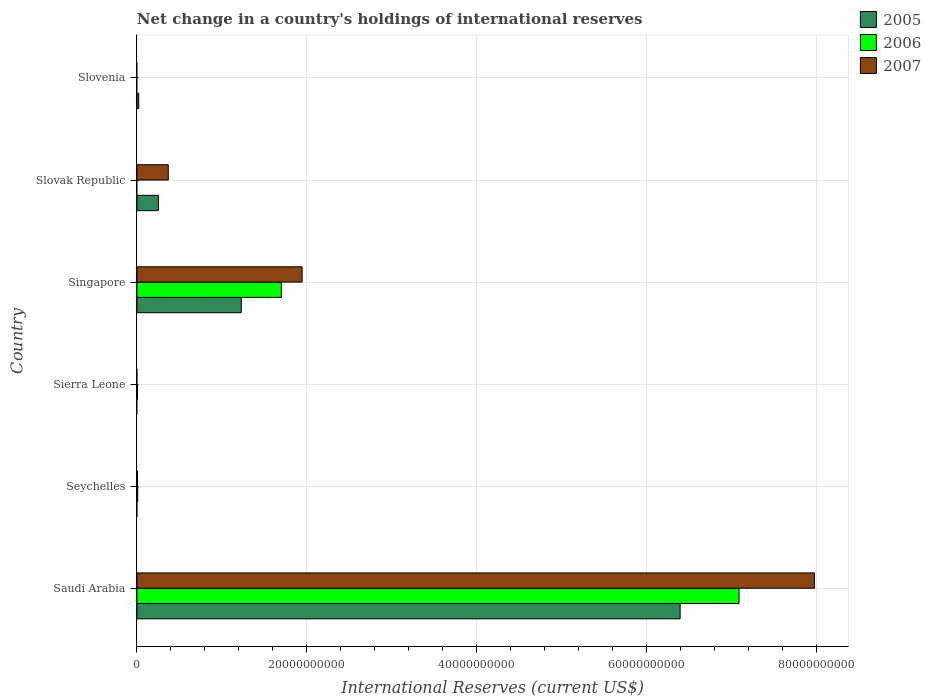How many bars are there on the 4th tick from the bottom?
Provide a succinct answer. 3. What is the label of the 3rd group of bars from the top?
Your answer should be compact. Singapore. In how many cases, is the number of bars for a given country not equal to the number of legend labels?
Offer a very short reply. 4. What is the international reserves in 2005 in Slovak Republic?
Offer a very short reply. 2.52e+09. Across all countries, what is the maximum international reserves in 2005?
Give a very brief answer. 6.40e+1. In which country was the international reserves in 2007 maximum?
Your answer should be compact. Saudi Arabia. What is the total international reserves in 2007 in the graph?
Offer a terse response. 1.03e+11. What is the difference between the international reserves in 2006 in Saudi Arabia and that in Singapore?
Keep it short and to the point. 5.39e+1. What is the difference between the international reserves in 2005 in Slovenia and the international reserves in 2007 in Seychelles?
Your response must be concise. 1.45e+08. What is the average international reserves in 2006 per country?
Your answer should be very brief. 1.47e+1. What is the difference between the international reserves in 2005 and international reserves in 2006 in Saudi Arabia?
Your response must be concise. -6.94e+09. In how many countries, is the international reserves in 2005 greater than 64000000000 US$?
Keep it short and to the point. 0. What is the ratio of the international reserves in 2007 in Saudi Arabia to that in Singapore?
Offer a very short reply. 4.1. What is the difference between the highest and the second highest international reserves in 2006?
Give a very brief answer. 5.39e+1. What is the difference between the highest and the lowest international reserves in 2005?
Your answer should be compact. 6.40e+1. Is the sum of the international reserves in 2007 in Saudi Arabia and Slovak Republic greater than the maximum international reserves in 2005 across all countries?
Ensure brevity in your answer.  Yes. Are all the bars in the graph horizontal?
Your answer should be very brief. Yes. Does the graph contain any zero values?
Your response must be concise. Yes. Does the graph contain grids?
Your answer should be compact. Yes. Where does the legend appear in the graph?
Offer a terse response. Top right. What is the title of the graph?
Ensure brevity in your answer.  Net change in a country's holdings of international reserves. Does "1975" appear as one of the legend labels in the graph?
Keep it short and to the point. No. What is the label or title of the X-axis?
Provide a succinct answer. International Reserves (current US$). What is the International Reserves (current US$) of 2005 in Saudi Arabia?
Ensure brevity in your answer.  6.40e+1. What is the International Reserves (current US$) in 2006 in Saudi Arabia?
Your answer should be very brief. 7.09e+1. What is the International Reserves (current US$) in 2007 in Saudi Arabia?
Keep it short and to the point. 7.98e+1. What is the International Reserves (current US$) in 2005 in Seychelles?
Your answer should be compact. 0. What is the International Reserves (current US$) of 2006 in Seychelles?
Your answer should be very brief. 9.32e+07. What is the International Reserves (current US$) of 2007 in Seychelles?
Provide a succinct answer. 6.12e+07. What is the International Reserves (current US$) of 2006 in Sierra Leone?
Ensure brevity in your answer.  6.04e+07. What is the International Reserves (current US$) in 2005 in Singapore?
Your answer should be very brief. 1.23e+1. What is the International Reserves (current US$) in 2006 in Singapore?
Offer a terse response. 1.70e+1. What is the International Reserves (current US$) in 2007 in Singapore?
Keep it short and to the point. 1.94e+1. What is the International Reserves (current US$) of 2005 in Slovak Republic?
Your answer should be compact. 2.52e+09. What is the International Reserves (current US$) of 2006 in Slovak Republic?
Provide a succinct answer. 0. What is the International Reserves (current US$) in 2007 in Slovak Republic?
Offer a very short reply. 3.69e+09. What is the International Reserves (current US$) in 2005 in Slovenia?
Provide a succinct answer. 2.06e+08. What is the International Reserves (current US$) of 2007 in Slovenia?
Your answer should be very brief. 0. Across all countries, what is the maximum International Reserves (current US$) in 2005?
Keep it short and to the point. 6.40e+1. Across all countries, what is the maximum International Reserves (current US$) in 2006?
Offer a terse response. 7.09e+1. Across all countries, what is the maximum International Reserves (current US$) in 2007?
Give a very brief answer. 7.98e+1. Across all countries, what is the minimum International Reserves (current US$) of 2006?
Give a very brief answer. 0. What is the total International Reserves (current US$) in 2005 in the graph?
Provide a short and direct response. 7.90e+1. What is the total International Reserves (current US$) of 2006 in the graph?
Offer a terse response. 8.81e+1. What is the total International Reserves (current US$) in 2007 in the graph?
Provide a succinct answer. 1.03e+11. What is the difference between the International Reserves (current US$) of 2006 in Saudi Arabia and that in Seychelles?
Offer a very short reply. 7.08e+1. What is the difference between the International Reserves (current US$) of 2007 in Saudi Arabia and that in Seychelles?
Your answer should be very brief. 7.97e+1. What is the difference between the International Reserves (current US$) of 2006 in Saudi Arabia and that in Sierra Leone?
Your answer should be very brief. 7.08e+1. What is the difference between the International Reserves (current US$) of 2005 in Saudi Arabia and that in Singapore?
Offer a terse response. 5.17e+1. What is the difference between the International Reserves (current US$) in 2006 in Saudi Arabia and that in Singapore?
Your answer should be very brief. 5.39e+1. What is the difference between the International Reserves (current US$) in 2007 in Saudi Arabia and that in Singapore?
Your response must be concise. 6.03e+1. What is the difference between the International Reserves (current US$) in 2005 in Saudi Arabia and that in Slovak Republic?
Your response must be concise. 6.14e+1. What is the difference between the International Reserves (current US$) of 2007 in Saudi Arabia and that in Slovak Republic?
Your answer should be very brief. 7.61e+1. What is the difference between the International Reserves (current US$) in 2005 in Saudi Arabia and that in Slovenia?
Offer a very short reply. 6.38e+1. What is the difference between the International Reserves (current US$) in 2006 in Seychelles and that in Sierra Leone?
Your response must be concise. 3.29e+07. What is the difference between the International Reserves (current US$) of 2006 in Seychelles and that in Singapore?
Provide a succinct answer. -1.69e+1. What is the difference between the International Reserves (current US$) of 2007 in Seychelles and that in Singapore?
Ensure brevity in your answer.  -1.94e+1. What is the difference between the International Reserves (current US$) in 2007 in Seychelles and that in Slovak Republic?
Offer a terse response. -3.63e+09. What is the difference between the International Reserves (current US$) of 2006 in Sierra Leone and that in Singapore?
Provide a short and direct response. -1.69e+1. What is the difference between the International Reserves (current US$) of 2005 in Singapore and that in Slovak Republic?
Provide a short and direct response. 9.76e+09. What is the difference between the International Reserves (current US$) in 2007 in Singapore and that in Slovak Republic?
Ensure brevity in your answer.  1.58e+1. What is the difference between the International Reserves (current US$) of 2005 in Singapore and that in Slovenia?
Your answer should be very brief. 1.21e+1. What is the difference between the International Reserves (current US$) in 2005 in Slovak Republic and that in Slovenia?
Your response must be concise. 2.32e+09. What is the difference between the International Reserves (current US$) of 2005 in Saudi Arabia and the International Reserves (current US$) of 2006 in Seychelles?
Your answer should be compact. 6.39e+1. What is the difference between the International Reserves (current US$) of 2005 in Saudi Arabia and the International Reserves (current US$) of 2007 in Seychelles?
Provide a short and direct response. 6.39e+1. What is the difference between the International Reserves (current US$) of 2006 in Saudi Arabia and the International Reserves (current US$) of 2007 in Seychelles?
Offer a terse response. 7.08e+1. What is the difference between the International Reserves (current US$) in 2005 in Saudi Arabia and the International Reserves (current US$) in 2006 in Sierra Leone?
Ensure brevity in your answer.  6.39e+1. What is the difference between the International Reserves (current US$) in 2005 in Saudi Arabia and the International Reserves (current US$) in 2006 in Singapore?
Make the answer very short. 4.70e+1. What is the difference between the International Reserves (current US$) in 2005 in Saudi Arabia and the International Reserves (current US$) in 2007 in Singapore?
Your answer should be compact. 4.45e+1. What is the difference between the International Reserves (current US$) in 2006 in Saudi Arabia and the International Reserves (current US$) in 2007 in Singapore?
Keep it short and to the point. 5.15e+1. What is the difference between the International Reserves (current US$) in 2005 in Saudi Arabia and the International Reserves (current US$) in 2007 in Slovak Republic?
Keep it short and to the point. 6.03e+1. What is the difference between the International Reserves (current US$) in 2006 in Saudi Arabia and the International Reserves (current US$) in 2007 in Slovak Republic?
Provide a succinct answer. 6.72e+1. What is the difference between the International Reserves (current US$) of 2006 in Seychelles and the International Reserves (current US$) of 2007 in Singapore?
Offer a very short reply. -1.94e+1. What is the difference between the International Reserves (current US$) in 2006 in Seychelles and the International Reserves (current US$) in 2007 in Slovak Republic?
Provide a short and direct response. -3.59e+09. What is the difference between the International Reserves (current US$) in 2006 in Sierra Leone and the International Reserves (current US$) in 2007 in Singapore?
Provide a succinct answer. -1.94e+1. What is the difference between the International Reserves (current US$) in 2006 in Sierra Leone and the International Reserves (current US$) in 2007 in Slovak Republic?
Your response must be concise. -3.63e+09. What is the difference between the International Reserves (current US$) of 2005 in Singapore and the International Reserves (current US$) of 2007 in Slovak Republic?
Make the answer very short. 8.60e+09. What is the difference between the International Reserves (current US$) in 2006 in Singapore and the International Reserves (current US$) in 2007 in Slovak Republic?
Give a very brief answer. 1.33e+1. What is the average International Reserves (current US$) of 2005 per country?
Provide a succinct answer. 1.32e+1. What is the average International Reserves (current US$) of 2006 per country?
Ensure brevity in your answer.  1.47e+1. What is the average International Reserves (current US$) of 2007 per country?
Your response must be concise. 1.72e+1. What is the difference between the International Reserves (current US$) in 2005 and International Reserves (current US$) in 2006 in Saudi Arabia?
Your response must be concise. -6.94e+09. What is the difference between the International Reserves (current US$) of 2005 and International Reserves (current US$) of 2007 in Saudi Arabia?
Provide a short and direct response. -1.58e+1. What is the difference between the International Reserves (current US$) in 2006 and International Reserves (current US$) in 2007 in Saudi Arabia?
Keep it short and to the point. -8.88e+09. What is the difference between the International Reserves (current US$) in 2006 and International Reserves (current US$) in 2007 in Seychelles?
Give a very brief answer. 3.20e+07. What is the difference between the International Reserves (current US$) of 2005 and International Reserves (current US$) of 2006 in Singapore?
Ensure brevity in your answer.  -4.72e+09. What is the difference between the International Reserves (current US$) in 2005 and International Reserves (current US$) in 2007 in Singapore?
Ensure brevity in your answer.  -7.16e+09. What is the difference between the International Reserves (current US$) in 2006 and International Reserves (current US$) in 2007 in Singapore?
Offer a very short reply. -2.44e+09. What is the difference between the International Reserves (current US$) of 2005 and International Reserves (current US$) of 2007 in Slovak Republic?
Ensure brevity in your answer.  -1.17e+09. What is the ratio of the International Reserves (current US$) of 2006 in Saudi Arabia to that in Seychelles?
Keep it short and to the point. 760.58. What is the ratio of the International Reserves (current US$) of 2007 in Saudi Arabia to that in Seychelles?
Your response must be concise. 1302.82. What is the ratio of the International Reserves (current US$) of 2006 in Saudi Arabia to that in Sierra Leone?
Offer a very short reply. 1174.83. What is the ratio of the International Reserves (current US$) in 2005 in Saudi Arabia to that in Singapore?
Your answer should be compact. 5.21. What is the ratio of the International Reserves (current US$) in 2006 in Saudi Arabia to that in Singapore?
Provide a short and direct response. 4.17. What is the ratio of the International Reserves (current US$) in 2007 in Saudi Arabia to that in Singapore?
Your answer should be compact. 4.1. What is the ratio of the International Reserves (current US$) in 2005 in Saudi Arabia to that in Slovak Republic?
Offer a terse response. 25.37. What is the ratio of the International Reserves (current US$) of 2007 in Saudi Arabia to that in Slovak Republic?
Your response must be concise. 21.64. What is the ratio of the International Reserves (current US$) in 2005 in Saudi Arabia to that in Slovenia?
Make the answer very short. 309.98. What is the ratio of the International Reserves (current US$) in 2006 in Seychelles to that in Sierra Leone?
Keep it short and to the point. 1.54. What is the ratio of the International Reserves (current US$) of 2006 in Seychelles to that in Singapore?
Ensure brevity in your answer.  0.01. What is the ratio of the International Reserves (current US$) in 2007 in Seychelles to that in Singapore?
Your answer should be compact. 0. What is the ratio of the International Reserves (current US$) in 2007 in Seychelles to that in Slovak Republic?
Provide a short and direct response. 0.02. What is the ratio of the International Reserves (current US$) in 2006 in Sierra Leone to that in Singapore?
Provide a succinct answer. 0. What is the ratio of the International Reserves (current US$) of 2005 in Singapore to that in Slovak Republic?
Give a very brief answer. 4.87. What is the ratio of the International Reserves (current US$) of 2007 in Singapore to that in Slovak Republic?
Your answer should be compact. 5.27. What is the ratio of the International Reserves (current US$) in 2005 in Singapore to that in Slovenia?
Your answer should be very brief. 59.52. What is the ratio of the International Reserves (current US$) of 2005 in Slovak Republic to that in Slovenia?
Offer a terse response. 12.22. What is the difference between the highest and the second highest International Reserves (current US$) in 2005?
Your response must be concise. 5.17e+1. What is the difference between the highest and the second highest International Reserves (current US$) of 2006?
Your answer should be very brief. 5.39e+1. What is the difference between the highest and the second highest International Reserves (current US$) in 2007?
Keep it short and to the point. 6.03e+1. What is the difference between the highest and the lowest International Reserves (current US$) of 2005?
Give a very brief answer. 6.40e+1. What is the difference between the highest and the lowest International Reserves (current US$) in 2006?
Your answer should be very brief. 7.09e+1. What is the difference between the highest and the lowest International Reserves (current US$) in 2007?
Your answer should be compact. 7.98e+1. 